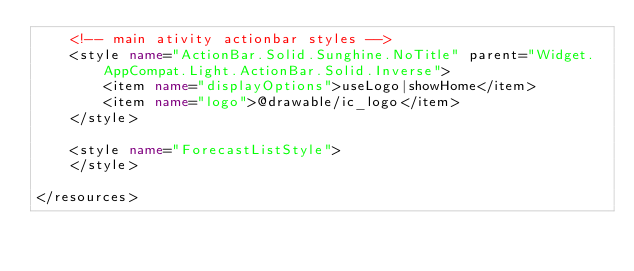Convert code to text. <code><loc_0><loc_0><loc_500><loc_500><_XML_>    <!-- main ativity actionbar styles -->
    <style name="ActionBar.Solid.Sunghine.NoTitle" parent="Widget.AppCompat.Light.ActionBar.Solid.Inverse">
        <item name="displayOptions">useLogo|showHome</item>
        <item name="logo">@drawable/ic_logo</item>
    </style>

    <style name="ForecastListStyle">
    </style>

</resources>
</code> 